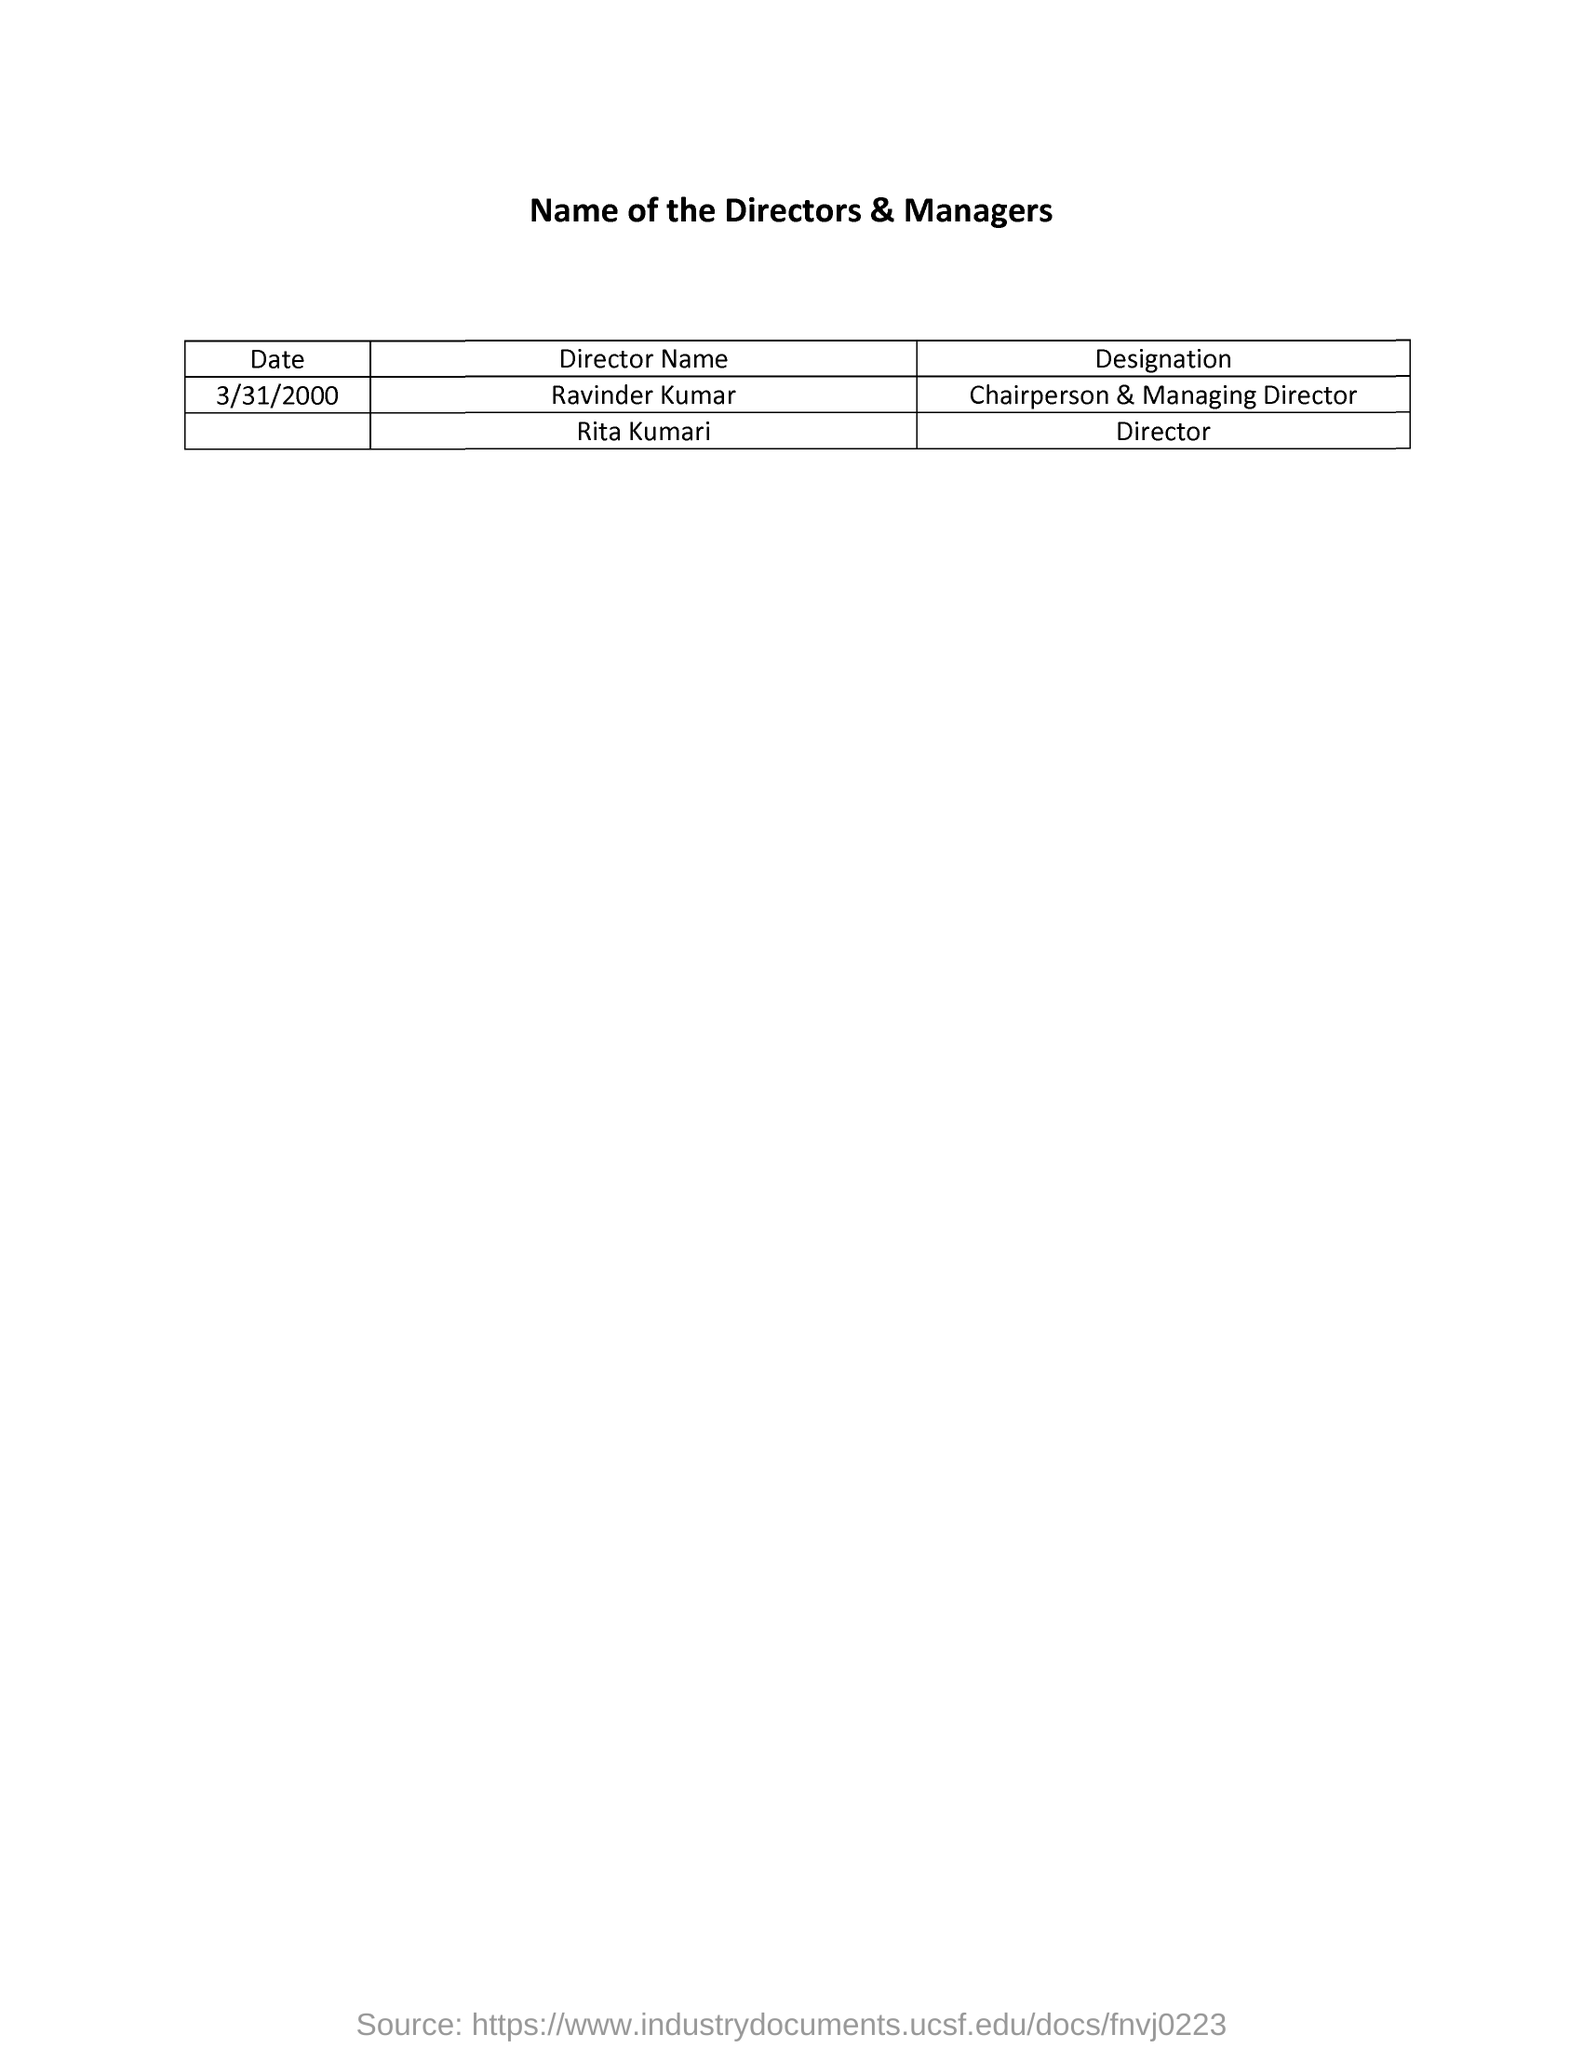Which date is mentioned in the list?
Provide a succinct answer. 3/31/2000. What is the name of the Chairperson and Managing director?
Give a very brief answer. Ravinder kumar. What is the designation of Rita Kumari?
Offer a terse response. Director. 